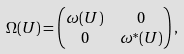<formula> <loc_0><loc_0><loc_500><loc_500>\Omega ( U ) & = \begin{pmatrix} \omega ( U ) & 0 \\ 0 & \omega ^ { * } ( U ) \end{pmatrix} ,</formula> 